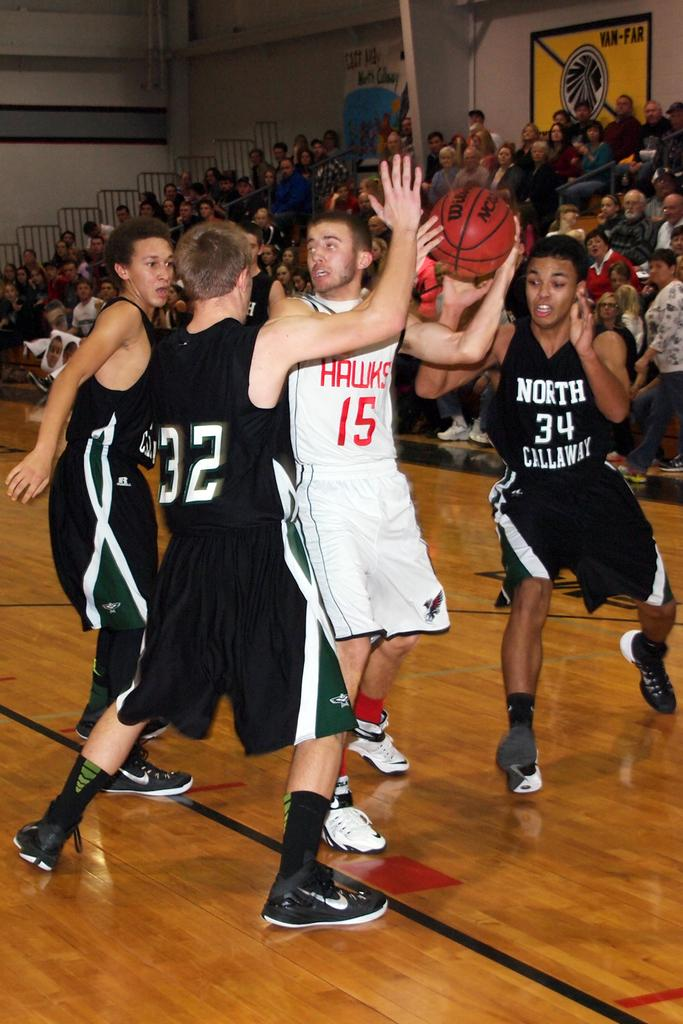<image>
Provide a brief description of the given image. North Callaway and the Hawks are playing a game of basketball. 